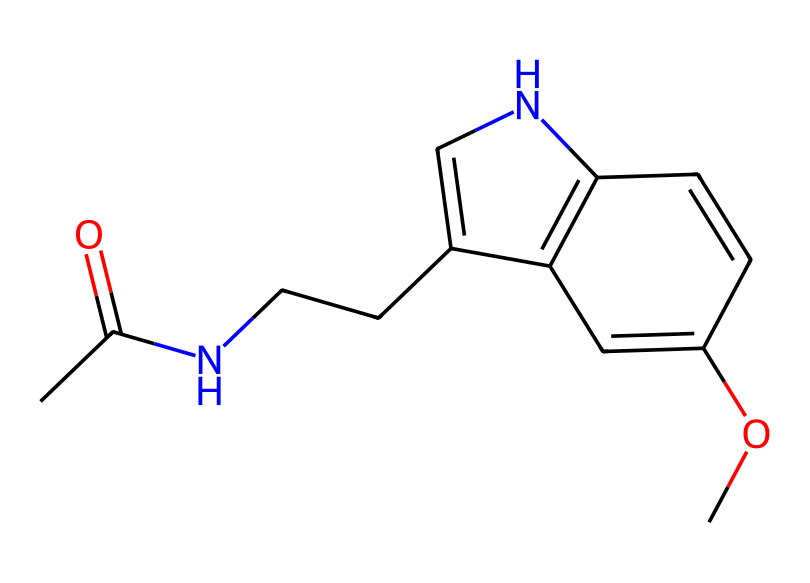What is the molecular formula of this compound? To find the molecular formula, we need to count the number of each type of atom in the chemical structure. From the SMILES, we identify carbon (C), hydrogen (H), nitrogen (N), and oxygen (O) atoms. After tallying them up, we find that there are 13 carbon atoms, 16 hydrogen atoms, 2 nitrogen atoms, and 2 oxygen atoms. Thus, the molecular formula is C13H16N2O2.
Answer: C13H16N2O2 How many nitrogen atoms are present in the structure? By examining the SMILES representation, we can directly count the nitrogen atoms represented in the chemical. The 'N' in the structure indicates the presence of nitrogen. There are two 'N's present, so the total is two nitrogen atoms.
Answer: 2 What functional groups are identified in this compound? To determine the functional groups, we analyze the structure and identify key features. In this compound, we can see an amide group (due to the presence of the carbonyl and nitrogen), an ether (indicated by the OC), and perhaps a secondary amine (due to the nitrogen connected to two carbon atoms). These combined indicate the functional groups present in the compound.
Answer: amide, ether, secondary amine What type of chemical is melatonin classified as? Melatonin is primarily recognized as a hormone that regulates sleep. Given its structure and its role in medicine, it is classified as a medicinal compound. Its structure shows a complex organic molecule that interacts with biological receptors, affirming its medicinal compound classification.
Answer: medicinal compound Which part of this chemical structure is responsible for its interaction with receptors? In the structure of melatonin, the indole structure (indicated by the fused rings containing nitrogen) is primarily responsible for its biological activity, as it mimics the natural hormone melatonin produced by the body. This part allows it to interact effectively with melatonin receptors in the body to promote sleep.
Answer: indole structure 